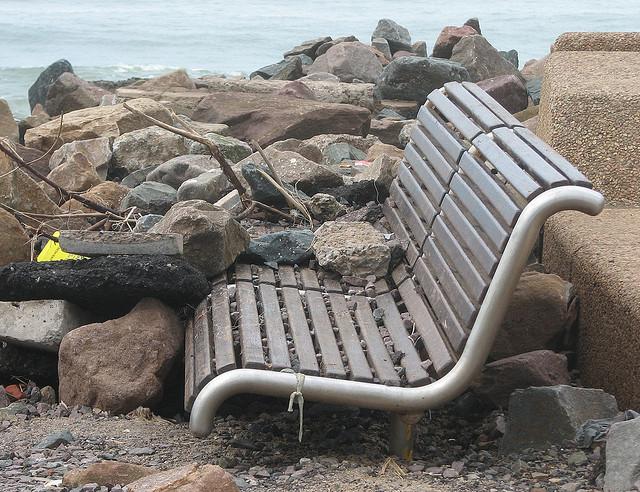Would you like to sit on this bench?
Be succinct. No. What is the frame of the bench made of?
Give a very brief answer. Metal. What is the bench covered in?
Short answer required. Rocks. 